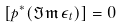Convert formula to latex. <formula><loc_0><loc_0><loc_500><loc_500>[ p ^ { * } ( \Im \mathfrak { m } \, \epsilon _ { t } ) ] = 0</formula> 